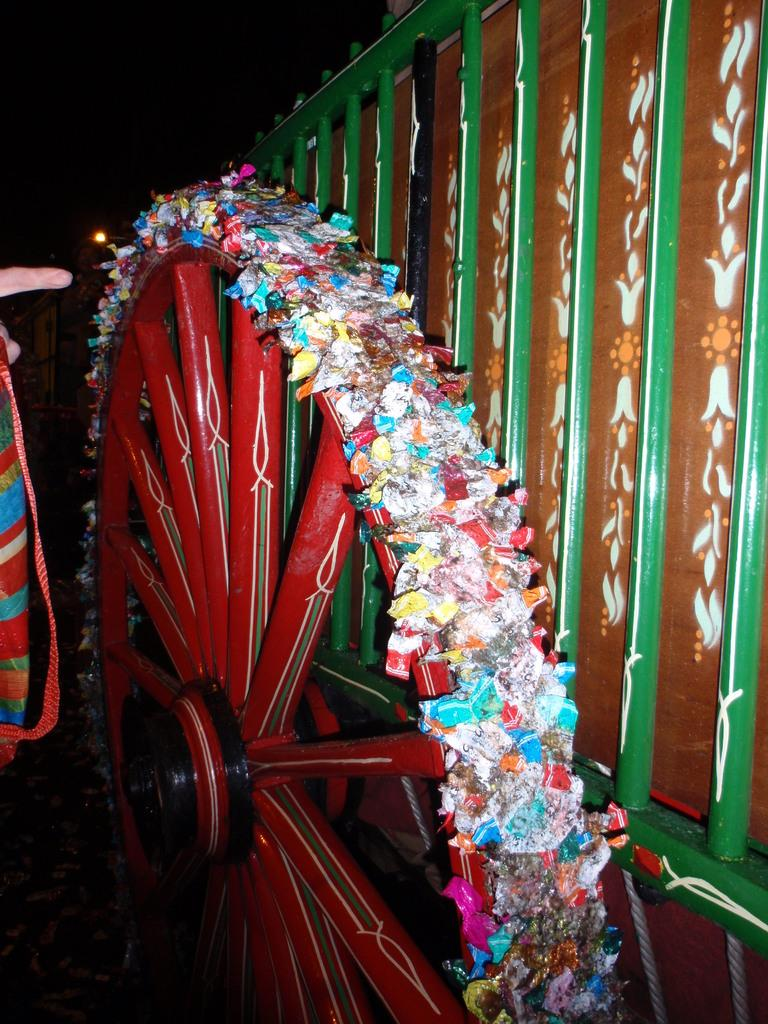What is the main subject in the picture? The main subject in the picture is a decorated wheel. Can you describe the wheel in more detail? The wheel appears to be decorated, but the specific design or pattern cannot be determined from the image. What else is visible in the picture? There is an iron fence beside the wheel. What type of nation is represented by the decorated wheel in the image? The image does not depict a nation or any national symbols, so it cannot be determined which nation, if any, is represented by the decorated wheel. 